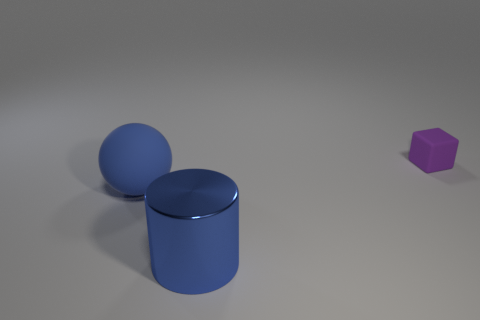What is the color of the rubber object right of the large blue object that is in front of the rubber object in front of the small purple thing?
Give a very brief answer. Purple. What shape is the thing that is both behind the metallic cylinder and on the left side of the small matte object?
Your answer should be compact. Sphere. Is there any other thing that is the same size as the blue sphere?
Offer a very short reply. Yes. What color is the thing that is behind the big blue object behind the blue cylinder?
Ensure brevity in your answer.  Purple. What shape is the rubber object that is to the left of the object behind the rubber object on the left side of the rubber block?
Provide a succinct answer. Sphere. What size is the thing that is behind the blue shiny cylinder and to the left of the matte cube?
Keep it short and to the point. Large. How many tiny things are the same color as the big cylinder?
Provide a succinct answer. 0. There is a sphere that is the same color as the shiny cylinder; what is it made of?
Give a very brief answer. Rubber. What is the material of the large sphere?
Ensure brevity in your answer.  Rubber. Do the block right of the large blue ball and the big blue cylinder have the same material?
Your response must be concise. No. 